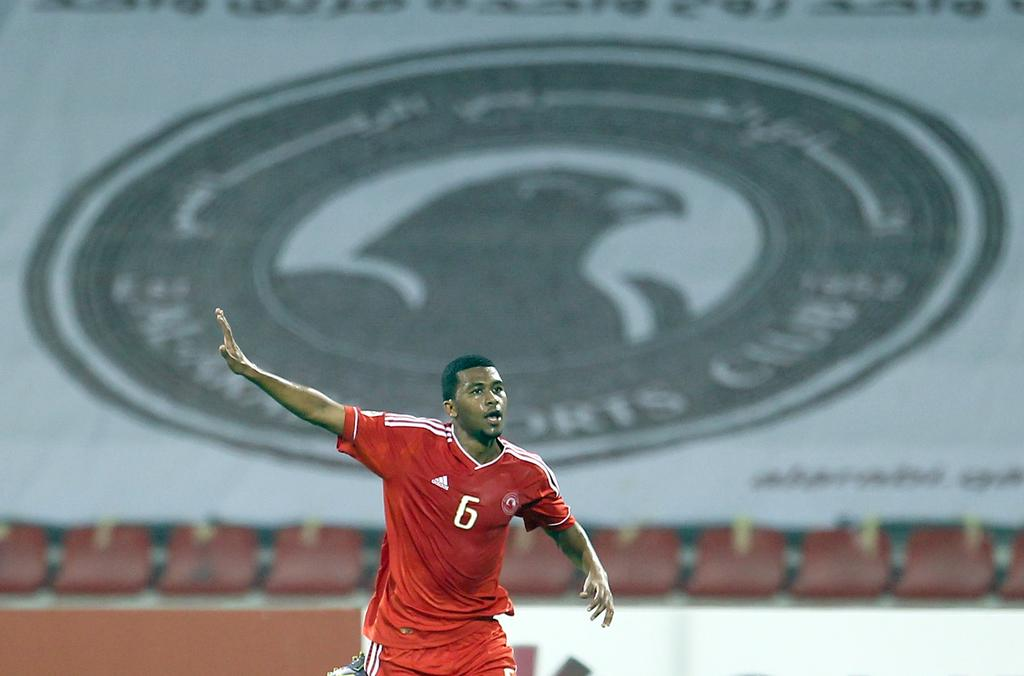<image>
Render a clear and concise summary of the photo. Man wearing a red number 6 jersey celebrating for something. 